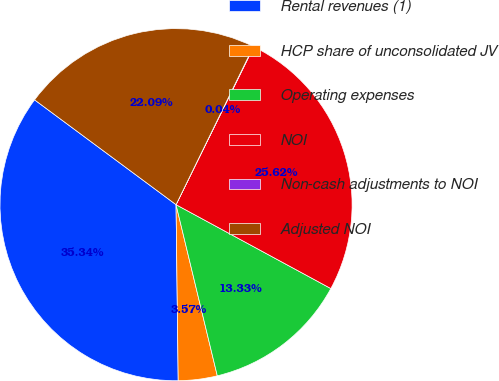Convert chart. <chart><loc_0><loc_0><loc_500><loc_500><pie_chart><fcel>Rental revenues (1)<fcel>HCP share of unconsolidated JV<fcel>Operating expenses<fcel>NOI<fcel>Non-cash adjustments to NOI<fcel>Adjusted NOI<nl><fcel>35.34%<fcel>3.57%<fcel>13.33%<fcel>25.62%<fcel>0.04%<fcel>22.09%<nl></chart> 